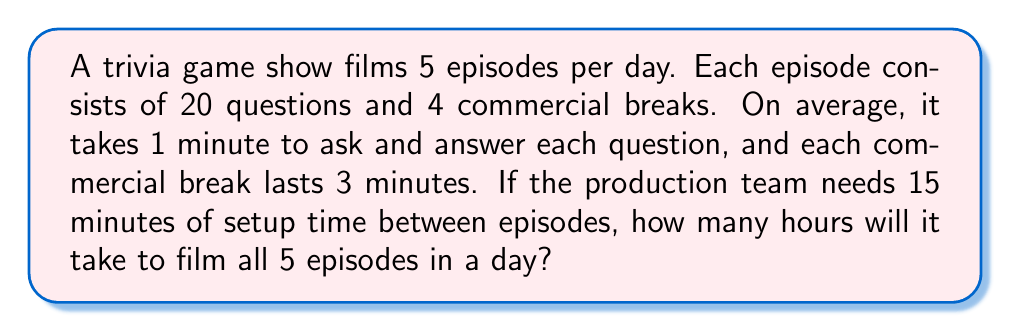What is the answer to this math problem? Let's break this down step-by-step:

1. Calculate the time for questions per episode:
   $20 \text{ questions} \times 1 \text{ minute} = 20 \text{ minutes}$

2. Calculate the time for commercial breaks per episode:
   $4 \text{ breaks} \times 3 \text{ minutes} = 12 \text{ minutes}$

3. Total time per episode:
   $20 \text{ minutes (questions)} + 12 \text{ minutes (breaks)} = 32 \text{ minutes}$

4. Time for 5 episodes:
   $5 \times 32 \text{ minutes} = 160 \text{ minutes}$

5. Add setup time between episodes:
   $4 \text{ setups} \times 15 \text{ minutes} = 60 \text{ minutes}$
   (Note: We only need 4 setups because there's no setup after the last episode)

6. Total time:
   $160 \text{ minutes (episodes)} + 60 \text{ minutes (setups)} = 220 \text{ minutes}$

7. Convert minutes to hours:
   $220 \text{ minutes} \div 60 \text{ minutes/hour} = \frac{11}{3} \text{ hours} = 3\frac{2}{3} \text{ hours}$

Therefore, it will take $3\frac{2}{3}$ hours to film all 5 episodes in a day.
Answer: $3\frac{2}{3}$ hours 